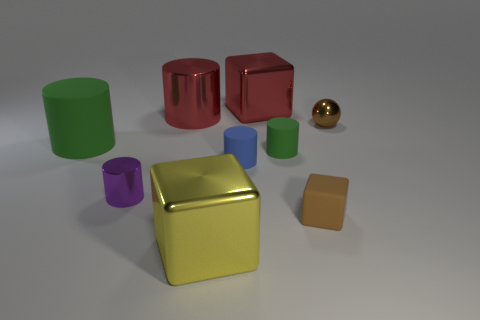What size is the green thing that is left of the big metal object that is in front of the red metallic cylinder left of the small blue rubber object?
Keep it short and to the point. Large. Are there any small green rubber things left of the big yellow metallic cube?
Offer a very short reply. No. The yellow object that is the same material as the red cylinder is what size?
Ensure brevity in your answer.  Large. How many small metallic objects are the same shape as the small brown rubber object?
Offer a terse response. 0. Are the brown block and the block behind the large red metal cylinder made of the same material?
Ensure brevity in your answer.  No. Is the number of tiny green objects behind the small metal sphere greater than the number of tiny green blocks?
Offer a very short reply. No. The rubber thing that is the same color as the metal ball is what shape?
Ensure brevity in your answer.  Cube. Is there a small brown ball that has the same material as the blue thing?
Provide a succinct answer. No. Are the cylinder that is behind the big rubber object and the large cube in front of the metallic sphere made of the same material?
Keep it short and to the point. Yes. Are there the same number of tiny rubber cylinders in front of the blue matte cylinder and large metallic cylinders that are to the left of the purple cylinder?
Your answer should be compact. Yes. 